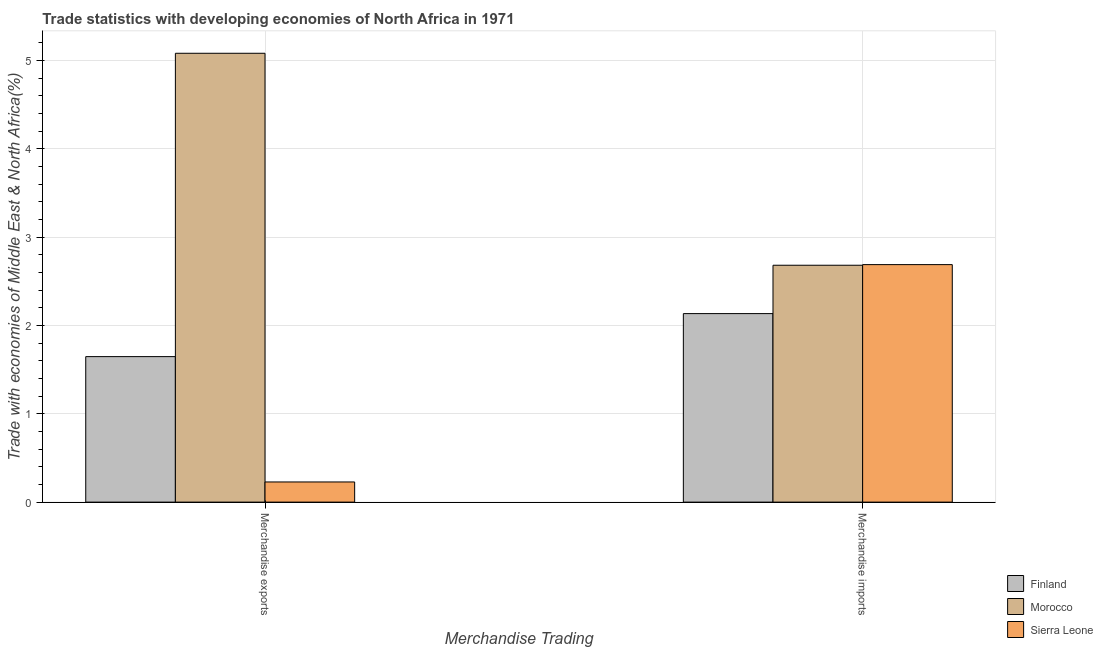How many different coloured bars are there?
Make the answer very short. 3. Are the number of bars on each tick of the X-axis equal?
Give a very brief answer. Yes. What is the label of the 1st group of bars from the left?
Ensure brevity in your answer.  Merchandise exports. What is the merchandise imports in Finland?
Offer a very short reply. 2.13. Across all countries, what is the maximum merchandise imports?
Give a very brief answer. 2.69. Across all countries, what is the minimum merchandise imports?
Make the answer very short. 2.13. In which country was the merchandise exports maximum?
Offer a terse response. Morocco. In which country was the merchandise exports minimum?
Make the answer very short. Sierra Leone. What is the total merchandise imports in the graph?
Your answer should be very brief. 7.51. What is the difference between the merchandise imports in Morocco and that in Sierra Leone?
Give a very brief answer. -0.01. What is the difference between the merchandise exports in Morocco and the merchandise imports in Sierra Leone?
Make the answer very short. 2.39. What is the average merchandise exports per country?
Offer a terse response. 2.32. What is the difference between the merchandise exports and merchandise imports in Sierra Leone?
Offer a very short reply. -2.46. In how many countries, is the merchandise exports greater than 0.8 %?
Your answer should be very brief. 2. What is the ratio of the merchandise imports in Morocco to that in Sierra Leone?
Provide a succinct answer. 1. What does the 2nd bar from the right in Merchandise imports represents?
Your answer should be compact. Morocco. How many countries are there in the graph?
Provide a succinct answer. 3. What is the difference between two consecutive major ticks on the Y-axis?
Give a very brief answer. 1. Are the values on the major ticks of Y-axis written in scientific E-notation?
Give a very brief answer. No. Does the graph contain grids?
Ensure brevity in your answer.  Yes. How many legend labels are there?
Keep it short and to the point. 3. What is the title of the graph?
Your answer should be very brief. Trade statistics with developing economies of North Africa in 1971. What is the label or title of the X-axis?
Your response must be concise. Merchandise Trading. What is the label or title of the Y-axis?
Offer a very short reply. Trade with economies of Middle East & North Africa(%). What is the Trade with economies of Middle East & North Africa(%) of Finland in Merchandise exports?
Give a very brief answer. 1.65. What is the Trade with economies of Middle East & North Africa(%) of Morocco in Merchandise exports?
Make the answer very short. 5.08. What is the Trade with economies of Middle East & North Africa(%) in Sierra Leone in Merchandise exports?
Your answer should be very brief. 0.23. What is the Trade with economies of Middle East & North Africa(%) in Finland in Merchandise imports?
Provide a succinct answer. 2.13. What is the Trade with economies of Middle East & North Africa(%) in Morocco in Merchandise imports?
Offer a terse response. 2.68. What is the Trade with economies of Middle East & North Africa(%) in Sierra Leone in Merchandise imports?
Keep it short and to the point. 2.69. Across all Merchandise Trading, what is the maximum Trade with economies of Middle East & North Africa(%) in Finland?
Offer a very short reply. 2.13. Across all Merchandise Trading, what is the maximum Trade with economies of Middle East & North Africa(%) of Morocco?
Your answer should be compact. 5.08. Across all Merchandise Trading, what is the maximum Trade with economies of Middle East & North Africa(%) of Sierra Leone?
Your answer should be very brief. 2.69. Across all Merchandise Trading, what is the minimum Trade with economies of Middle East & North Africa(%) in Finland?
Provide a succinct answer. 1.65. Across all Merchandise Trading, what is the minimum Trade with economies of Middle East & North Africa(%) in Morocco?
Keep it short and to the point. 2.68. Across all Merchandise Trading, what is the minimum Trade with economies of Middle East & North Africa(%) in Sierra Leone?
Offer a terse response. 0.23. What is the total Trade with economies of Middle East & North Africa(%) in Finland in the graph?
Keep it short and to the point. 3.78. What is the total Trade with economies of Middle East & North Africa(%) of Morocco in the graph?
Your answer should be compact. 7.76. What is the total Trade with economies of Middle East & North Africa(%) in Sierra Leone in the graph?
Keep it short and to the point. 2.92. What is the difference between the Trade with economies of Middle East & North Africa(%) of Finland in Merchandise exports and that in Merchandise imports?
Provide a short and direct response. -0.49. What is the difference between the Trade with economies of Middle East & North Africa(%) in Sierra Leone in Merchandise exports and that in Merchandise imports?
Make the answer very short. -2.46. What is the difference between the Trade with economies of Middle East & North Africa(%) in Finland in Merchandise exports and the Trade with economies of Middle East & North Africa(%) in Morocco in Merchandise imports?
Keep it short and to the point. -1.03. What is the difference between the Trade with economies of Middle East & North Africa(%) of Finland in Merchandise exports and the Trade with economies of Middle East & North Africa(%) of Sierra Leone in Merchandise imports?
Make the answer very short. -1.04. What is the difference between the Trade with economies of Middle East & North Africa(%) of Morocco in Merchandise exports and the Trade with economies of Middle East & North Africa(%) of Sierra Leone in Merchandise imports?
Keep it short and to the point. 2.39. What is the average Trade with economies of Middle East & North Africa(%) in Finland per Merchandise Trading?
Provide a short and direct response. 1.89. What is the average Trade with economies of Middle East & North Africa(%) of Morocco per Merchandise Trading?
Your response must be concise. 3.88. What is the average Trade with economies of Middle East & North Africa(%) of Sierra Leone per Merchandise Trading?
Keep it short and to the point. 1.46. What is the difference between the Trade with economies of Middle East & North Africa(%) in Finland and Trade with economies of Middle East & North Africa(%) in Morocco in Merchandise exports?
Your answer should be very brief. -3.43. What is the difference between the Trade with economies of Middle East & North Africa(%) of Finland and Trade with economies of Middle East & North Africa(%) of Sierra Leone in Merchandise exports?
Provide a succinct answer. 1.42. What is the difference between the Trade with economies of Middle East & North Africa(%) of Morocco and Trade with economies of Middle East & North Africa(%) of Sierra Leone in Merchandise exports?
Ensure brevity in your answer.  4.85. What is the difference between the Trade with economies of Middle East & North Africa(%) in Finland and Trade with economies of Middle East & North Africa(%) in Morocco in Merchandise imports?
Ensure brevity in your answer.  -0.55. What is the difference between the Trade with economies of Middle East & North Africa(%) of Finland and Trade with economies of Middle East & North Africa(%) of Sierra Leone in Merchandise imports?
Your answer should be very brief. -0.55. What is the difference between the Trade with economies of Middle East & North Africa(%) of Morocco and Trade with economies of Middle East & North Africa(%) of Sierra Leone in Merchandise imports?
Make the answer very short. -0.01. What is the ratio of the Trade with economies of Middle East & North Africa(%) of Finland in Merchandise exports to that in Merchandise imports?
Give a very brief answer. 0.77. What is the ratio of the Trade with economies of Middle East & North Africa(%) in Morocco in Merchandise exports to that in Merchandise imports?
Offer a terse response. 1.89. What is the ratio of the Trade with economies of Middle East & North Africa(%) in Sierra Leone in Merchandise exports to that in Merchandise imports?
Your answer should be very brief. 0.08. What is the difference between the highest and the second highest Trade with economies of Middle East & North Africa(%) of Finland?
Make the answer very short. 0.49. What is the difference between the highest and the second highest Trade with economies of Middle East & North Africa(%) of Morocco?
Give a very brief answer. 2.4. What is the difference between the highest and the second highest Trade with economies of Middle East & North Africa(%) of Sierra Leone?
Your answer should be compact. 2.46. What is the difference between the highest and the lowest Trade with economies of Middle East & North Africa(%) of Finland?
Give a very brief answer. 0.49. What is the difference between the highest and the lowest Trade with economies of Middle East & North Africa(%) in Morocco?
Offer a very short reply. 2.4. What is the difference between the highest and the lowest Trade with economies of Middle East & North Africa(%) in Sierra Leone?
Give a very brief answer. 2.46. 